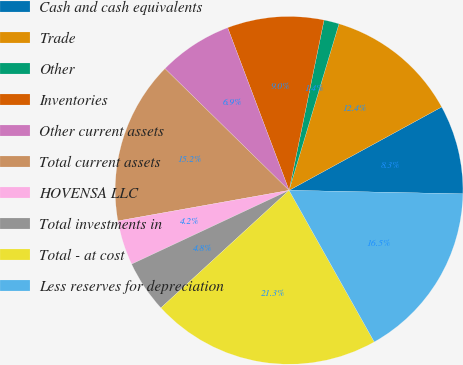<chart> <loc_0><loc_0><loc_500><loc_500><pie_chart><fcel>Cash and cash equivalents<fcel>Trade<fcel>Other<fcel>Inventories<fcel>Other current assets<fcel>Total current assets<fcel>HOVENSA LLC<fcel>Total investments in<fcel>Total - at cost<fcel>Less reserves for depreciation<nl><fcel>8.28%<fcel>12.41%<fcel>1.41%<fcel>8.97%<fcel>6.91%<fcel>15.16%<fcel>4.16%<fcel>4.84%<fcel>21.34%<fcel>16.53%<nl></chart> 